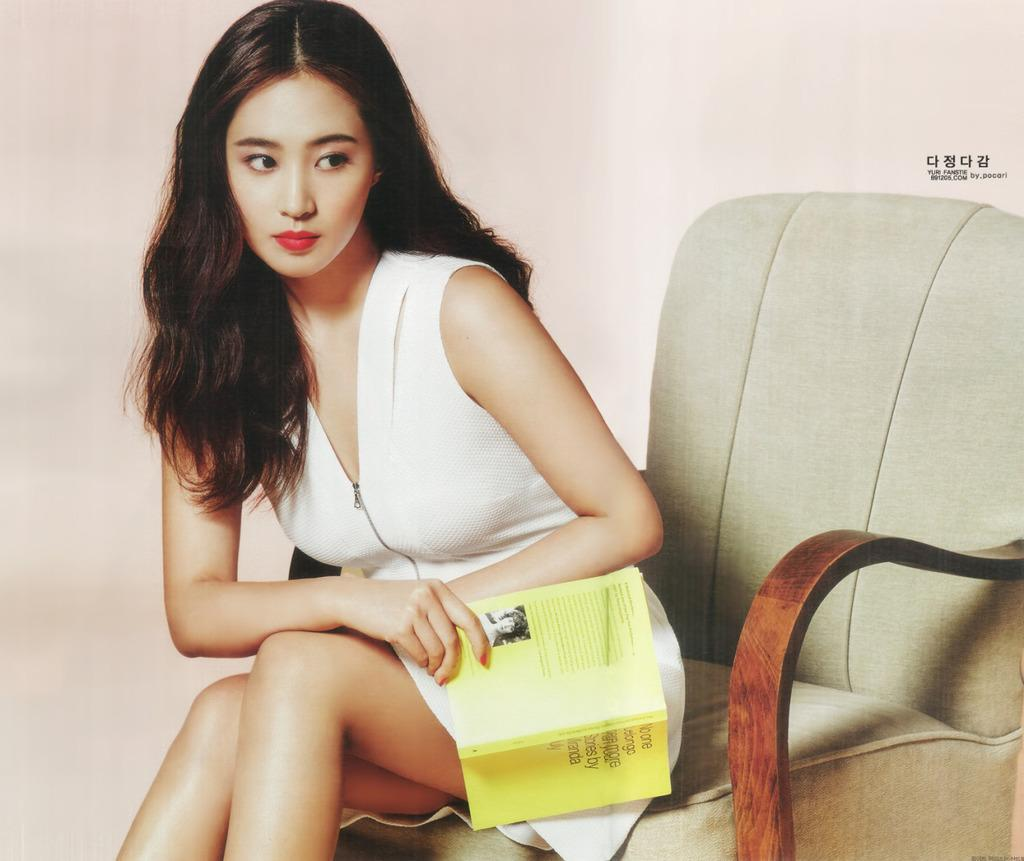Who is the main subject in the image? There is a woman in the image. What is the woman doing in the image? The woman is sitting on a chair. What is the woman holding in her hand? The woman is holding a book in her hand. How many ants can be seen crawling on the woman's arm in the image? There are no ants visible on the woman's arm in the image. What type of crack is present in the book the woman is holding? There is no crack visible in the book the woman is holding in the image. 